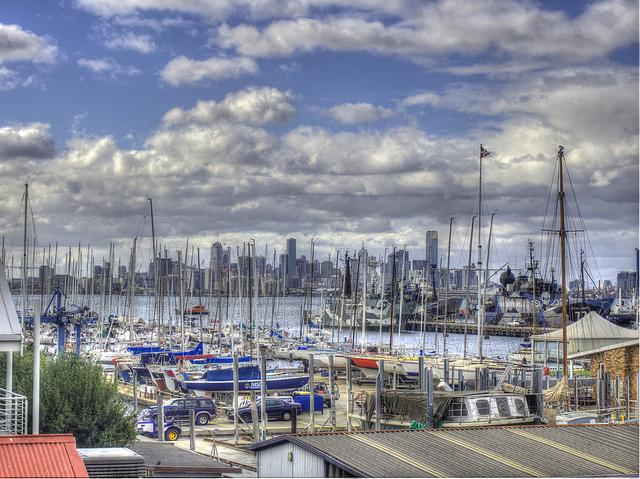How many boats are docked?
Give a very brief answer. 20. Where were these photos taken?
Concise answer only. Marina. Is it cloudy today?
Keep it brief. Yes. Is it cloudy?
Be succinct. Yes. Are the building floating in the water?
Be succinct. No. Is this a marina?
Write a very short answer. Yes. 